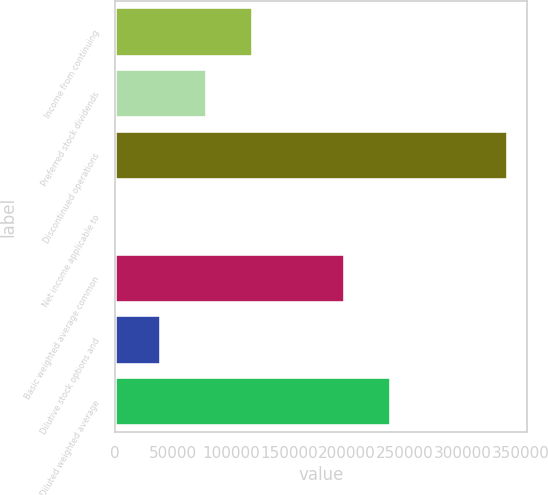Convert chart to OTSL. <chart><loc_0><loc_0><loc_500><loc_500><bar_chart><fcel>Income from continuing<fcel>Preferred stock dividends<fcel>Discontinued operations<fcel>Net income applicable to<fcel>Basic weighted average common<fcel>Dilutive stock options and<fcel>Diluted weighted average<nl><fcel>118927<fcel>79285.5<fcel>338392<fcel>2.67<fcel>198210<fcel>39644.1<fcel>237851<nl></chart> 